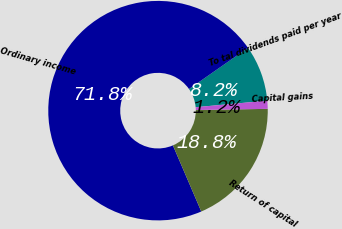Convert chart. <chart><loc_0><loc_0><loc_500><loc_500><pie_chart><fcel>To tal dividends paid per year<fcel>Ordinary income<fcel>Return of capital<fcel>Capital gains<nl><fcel>8.25%<fcel>71.75%<fcel>18.81%<fcel>1.19%<nl></chart> 